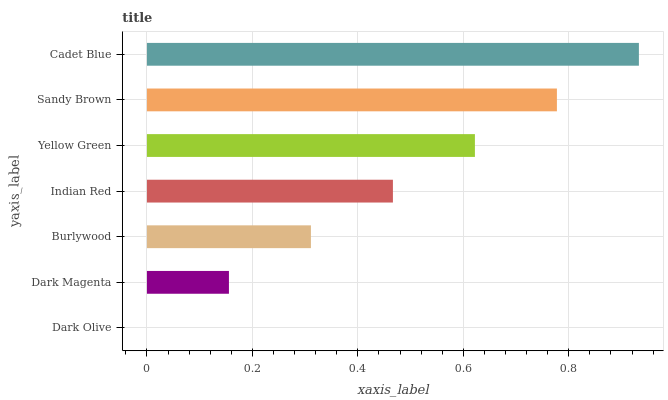Is Dark Olive the minimum?
Answer yes or no. Yes. Is Cadet Blue the maximum?
Answer yes or no. Yes. Is Dark Magenta the minimum?
Answer yes or no. No. Is Dark Magenta the maximum?
Answer yes or no. No. Is Dark Magenta greater than Dark Olive?
Answer yes or no. Yes. Is Dark Olive less than Dark Magenta?
Answer yes or no. Yes. Is Dark Olive greater than Dark Magenta?
Answer yes or no. No. Is Dark Magenta less than Dark Olive?
Answer yes or no. No. Is Indian Red the high median?
Answer yes or no. Yes. Is Indian Red the low median?
Answer yes or no. Yes. Is Dark Olive the high median?
Answer yes or no. No. Is Burlywood the low median?
Answer yes or no. No. 